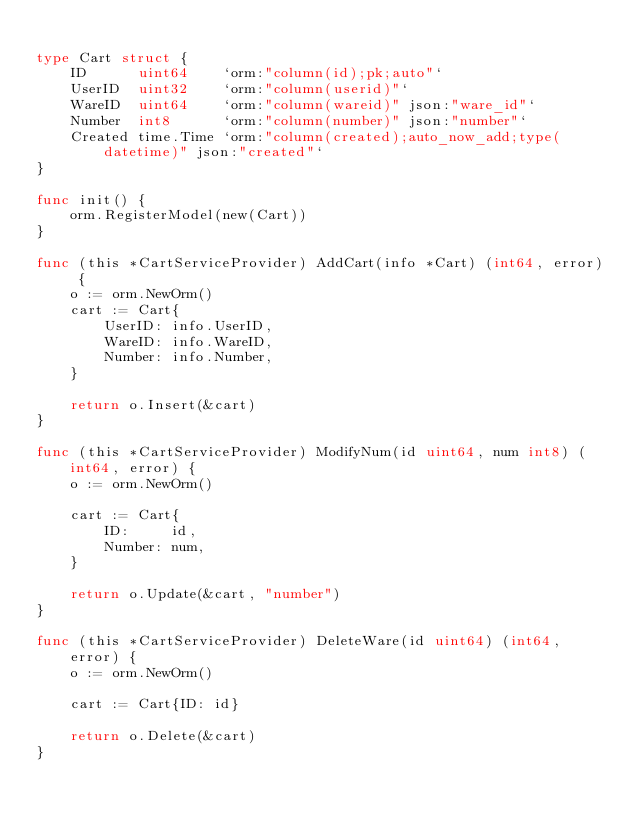Convert code to text. <code><loc_0><loc_0><loc_500><loc_500><_Go_>
type Cart struct {
	ID      uint64    `orm:"column(id);pk;auto"`
	UserID  uint32    `orm:"column(userid)"`
	WareID  uint64    `orm:"column(wareid)" json:"ware_id"`
	Number  int8      `orm:"column(number)" json:"number"`
	Created time.Time `orm:"column(created);auto_now_add;type(datetime)" json:"created"`
}

func init() {
	orm.RegisterModel(new(Cart))
}

func (this *CartServiceProvider) AddCart(info *Cart) (int64, error) {
	o := orm.NewOrm()
	cart := Cart{
		UserID: info.UserID,
		WareID: info.WareID,
		Number: info.Number,
	}

	return o.Insert(&cart)
}

func (this *CartServiceProvider) ModifyNum(id uint64, num int8) (int64, error) {
	o := orm.NewOrm()

	cart := Cart{
		ID:     id,
		Number: num,
	}

	return o.Update(&cart, "number")
}

func (this *CartServiceProvider) DeleteWare(id uint64) (int64, error) {
	o := orm.NewOrm()

	cart := Cart{ID: id}

	return o.Delete(&cart)
}
</code> 